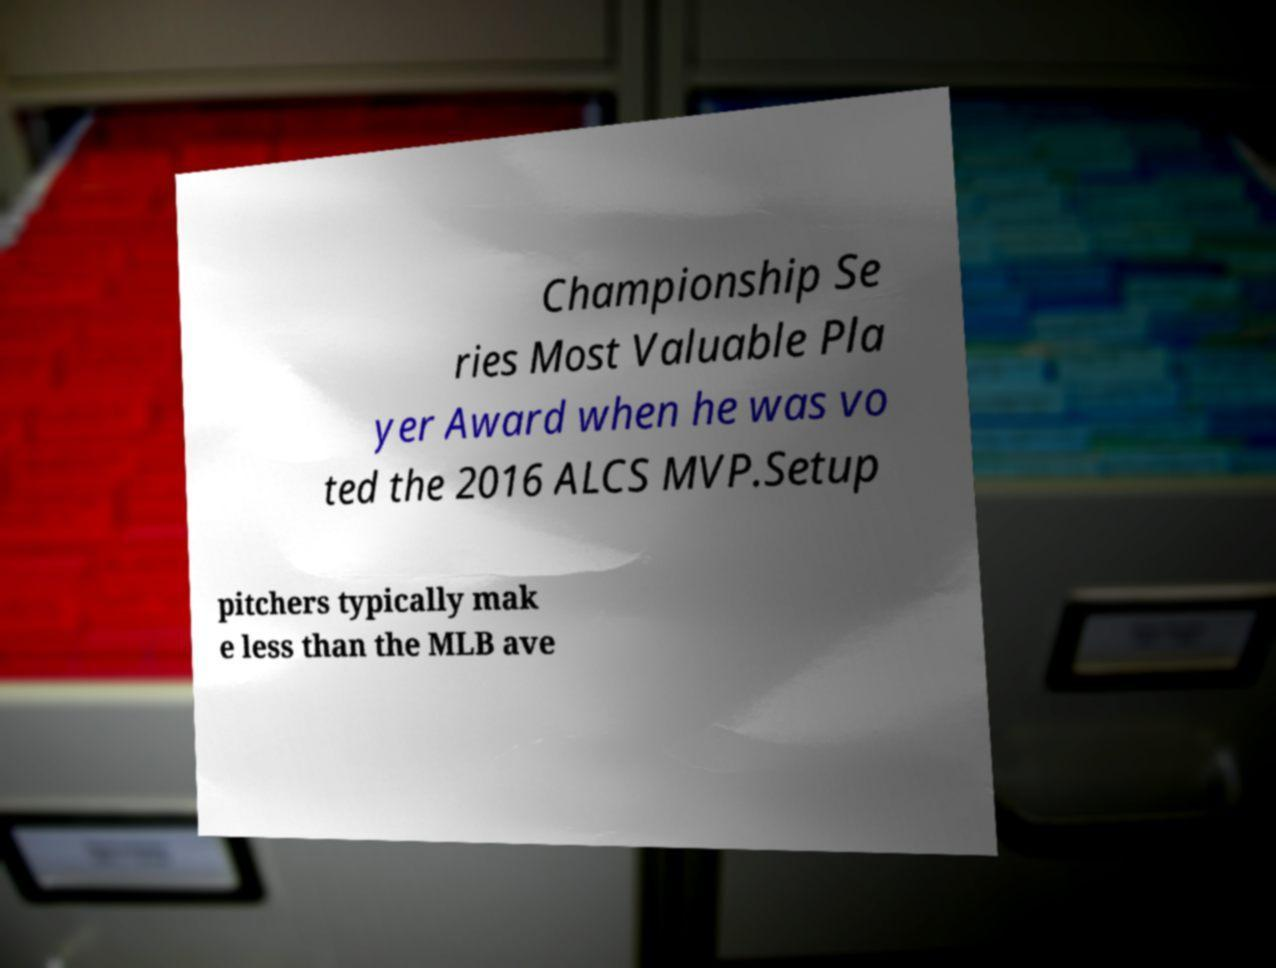Can you accurately transcribe the text from the provided image for me? Championship Se ries Most Valuable Pla yer Award when he was vo ted the 2016 ALCS MVP.Setup pitchers typically mak e less than the MLB ave 